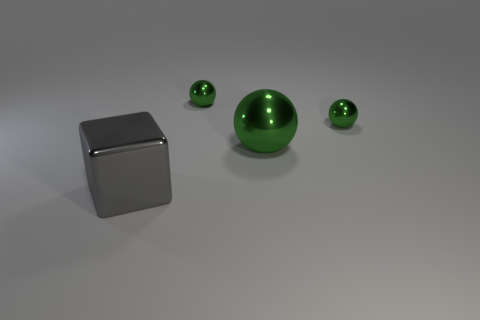How many other things are there of the same material as the big gray cube?
Ensure brevity in your answer.  3. Does the tiny thing that is on the right side of the big shiny sphere have the same color as the large shiny object behind the gray metal object?
Your response must be concise. Yes. Are there any tiny objects that have the same shape as the large gray thing?
Make the answer very short. No. The green object that is the same size as the gray metallic object is what shape?
Provide a short and direct response. Sphere. What number of other shiny spheres have the same color as the large sphere?
Make the answer very short. 2. What size is the thing that is to the right of the big green object?
Provide a succinct answer. Small. What number of green metallic balls are the same size as the gray metallic block?
Give a very brief answer. 1. The big object that is made of the same material as the cube is what color?
Make the answer very short. Green. Are there fewer big green balls to the right of the big block than tiny balls?
Your answer should be very brief. Yes. What is the shape of the big object that is the same material as the big gray cube?
Ensure brevity in your answer.  Sphere. 